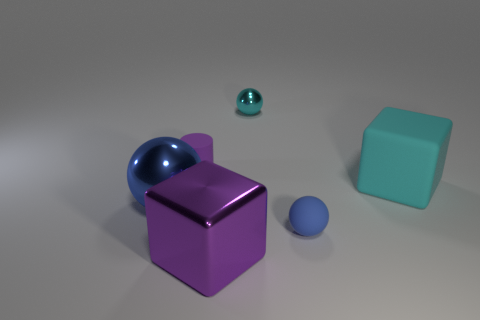How many other objects are there of the same material as the small purple cylinder?
Provide a short and direct response. 2. What number of things are either large blocks right of the cyan shiny object or tiny yellow metal blocks?
Your answer should be compact. 1. There is a matte thing that is on the left side of the metallic ball to the right of the big purple cube; what shape is it?
Make the answer very short. Cylinder. There is a large metal thing behind the purple metal block; is its shape the same as the tiny cyan metal object?
Make the answer very short. Yes. What is the color of the large block that is right of the purple shiny block?
Make the answer very short. Cyan. How many cubes are either big purple metal things or large gray rubber objects?
Offer a very short reply. 1. There is a purple thing in front of the big cyan thing right of the cyan ball; what is its size?
Offer a terse response. Large. Does the big shiny sphere have the same color as the sphere on the right side of the cyan metallic thing?
Offer a terse response. Yes. What number of shiny balls are to the left of the blue matte thing?
Keep it short and to the point. 2. Are there fewer blue rubber balls than purple objects?
Offer a terse response. Yes. 